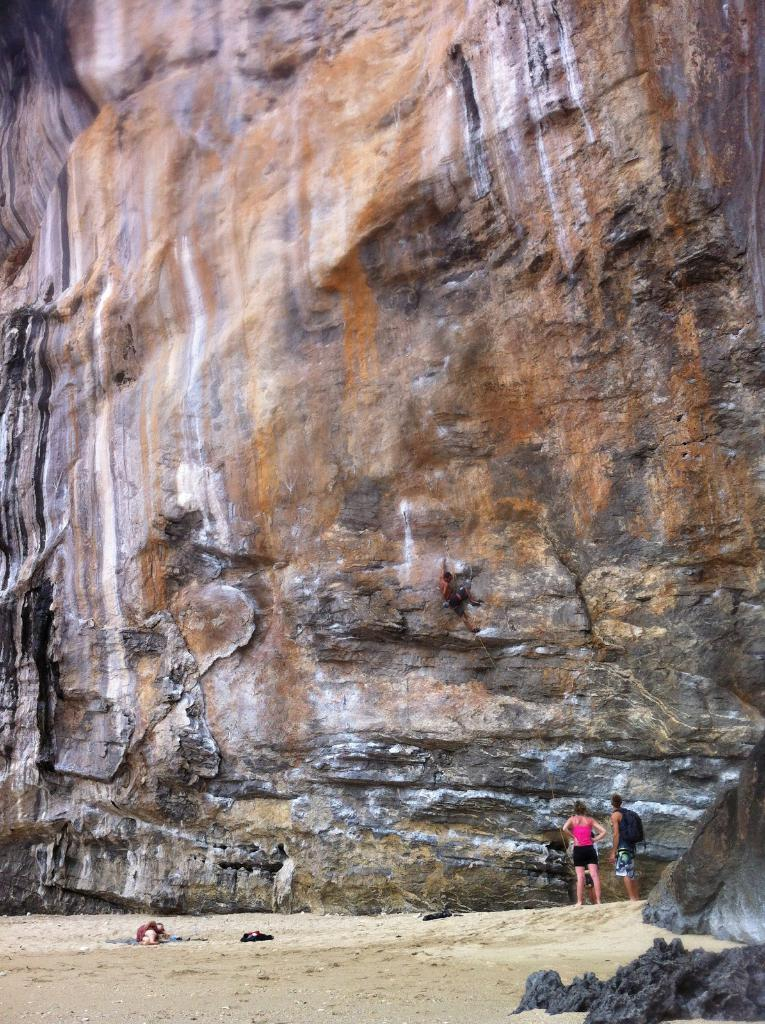How many people are in the image? There are two persons standing in the image. What is the person on the left wearing? The person on the left is wearing a pink and black dress. What can be seen in the background of the image? There is a rock visible in the background of the image. What time of day is it in the image, and what type of vehicle is parked nearby? The time of day cannot be determined from the image, and there is no vehicle visible in the image. 